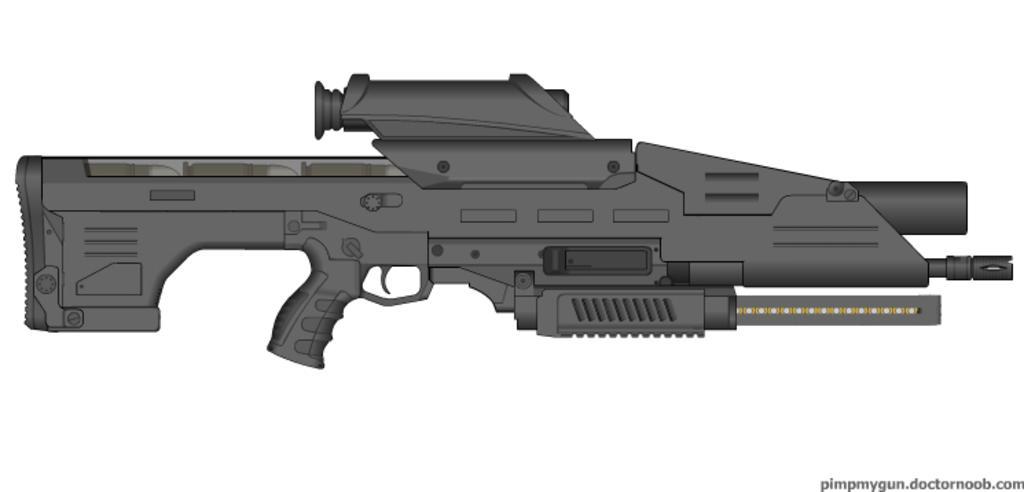In one or two sentences, can you explain what this image depicts? This is an animated image. I can see a rifle. At the bottom right side of the image, there is a watermark. The background is white in color. 